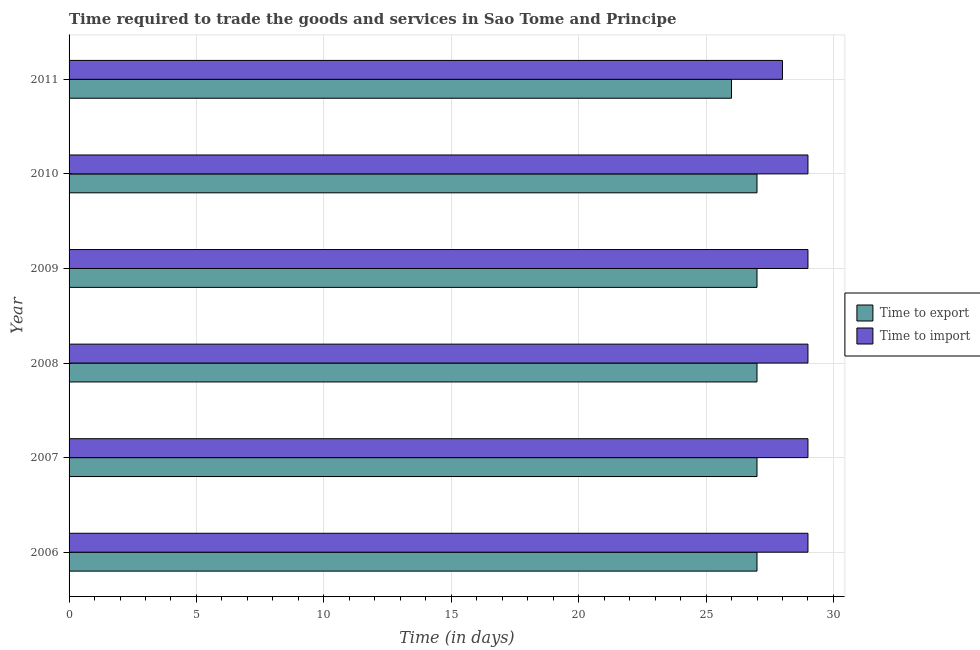How many different coloured bars are there?
Ensure brevity in your answer.  2. Are the number of bars per tick equal to the number of legend labels?
Ensure brevity in your answer.  Yes. Are the number of bars on each tick of the Y-axis equal?
Give a very brief answer. Yes. How many bars are there on the 2nd tick from the bottom?
Your answer should be compact. 2. What is the time to import in 2009?
Make the answer very short. 29. Across all years, what is the maximum time to export?
Make the answer very short. 27. Across all years, what is the minimum time to import?
Your response must be concise. 28. What is the total time to import in the graph?
Your response must be concise. 173. What is the difference between the time to export in 2009 and the time to import in 2007?
Give a very brief answer. -2. What is the average time to import per year?
Provide a short and direct response. 28.83. In the year 2009, what is the difference between the time to import and time to export?
Ensure brevity in your answer.  2. Is the time to import in 2009 less than that in 2011?
Ensure brevity in your answer.  No. What is the difference between the highest and the lowest time to import?
Your answer should be very brief. 1. In how many years, is the time to export greater than the average time to export taken over all years?
Give a very brief answer. 5. What does the 1st bar from the top in 2006 represents?
Keep it short and to the point. Time to import. What does the 2nd bar from the bottom in 2006 represents?
Keep it short and to the point. Time to import. Are all the bars in the graph horizontal?
Offer a terse response. Yes. How many years are there in the graph?
Provide a succinct answer. 6. What is the difference between two consecutive major ticks on the X-axis?
Give a very brief answer. 5. Are the values on the major ticks of X-axis written in scientific E-notation?
Your answer should be very brief. No. Does the graph contain any zero values?
Provide a short and direct response. No. Does the graph contain grids?
Keep it short and to the point. Yes. How are the legend labels stacked?
Offer a terse response. Vertical. What is the title of the graph?
Keep it short and to the point. Time required to trade the goods and services in Sao Tome and Principe. Does "Residents" appear as one of the legend labels in the graph?
Your answer should be very brief. No. What is the label or title of the X-axis?
Your response must be concise. Time (in days). What is the label or title of the Y-axis?
Give a very brief answer. Year. What is the Time (in days) in Time to export in 2006?
Provide a succinct answer. 27. What is the Time (in days) in Time to import in 2006?
Your answer should be very brief. 29. What is the Time (in days) of Time to export in 2007?
Keep it short and to the point. 27. What is the Time (in days) in Time to import in 2007?
Provide a succinct answer. 29. What is the Time (in days) of Time to export in 2008?
Give a very brief answer. 27. What is the Time (in days) of Time to export in 2009?
Your answer should be very brief. 27. What is the Time (in days) in Time to import in 2009?
Provide a short and direct response. 29. What is the Time (in days) of Time to import in 2010?
Provide a short and direct response. 29. What is the Time (in days) of Time to export in 2011?
Make the answer very short. 26. What is the Time (in days) of Time to import in 2011?
Keep it short and to the point. 28. Across all years, what is the maximum Time (in days) in Time to import?
Offer a very short reply. 29. Across all years, what is the minimum Time (in days) in Time to export?
Provide a short and direct response. 26. What is the total Time (in days) in Time to export in the graph?
Offer a terse response. 161. What is the total Time (in days) of Time to import in the graph?
Keep it short and to the point. 173. What is the difference between the Time (in days) of Time to export in 2006 and that in 2007?
Your answer should be compact. 0. What is the difference between the Time (in days) in Time to import in 2006 and that in 2007?
Offer a terse response. 0. What is the difference between the Time (in days) in Time to export in 2006 and that in 2008?
Ensure brevity in your answer.  0. What is the difference between the Time (in days) in Time to import in 2006 and that in 2008?
Offer a terse response. 0. What is the difference between the Time (in days) in Time to export in 2006 and that in 2009?
Provide a succinct answer. 0. What is the difference between the Time (in days) of Time to import in 2006 and that in 2009?
Offer a very short reply. 0. What is the difference between the Time (in days) of Time to export in 2006 and that in 2010?
Ensure brevity in your answer.  0. What is the difference between the Time (in days) of Time to import in 2006 and that in 2010?
Offer a terse response. 0. What is the difference between the Time (in days) in Time to export in 2006 and that in 2011?
Offer a very short reply. 1. What is the difference between the Time (in days) in Time to import in 2006 and that in 2011?
Offer a terse response. 1. What is the difference between the Time (in days) of Time to import in 2007 and that in 2009?
Make the answer very short. 0. What is the difference between the Time (in days) of Time to export in 2007 and that in 2011?
Offer a terse response. 1. What is the difference between the Time (in days) of Time to export in 2008 and that in 2009?
Keep it short and to the point. 0. What is the difference between the Time (in days) of Time to import in 2008 and that in 2009?
Your answer should be compact. 0. What is the difference between the Time (in days) of Time to import in 2008 and that in 2010?
Keep it short and to the point. 0. What is the difference between the Time (in days) in Time to export in 2009 and that in 2010?
Make the answer very short. 0. What is the difference between the Time (in days) in Time to export in 2009 and that in 2011?
Keep it short and to the point. 1. What is the difference between the Time (in days) of Time to import in 2009 and that in 2011?
Your answer should be very brief. 1. What is the difference between the Time (in days) of Time to export in 2006 and the Time (in days) of Time to import in 2009?
Give a very brief answer. -2. What is the difference between the Time (in days) of Time to export in 2006 and the Time (in days) of Time to import in 2011?
Make the answer very short. -1. What is the difference between the Time (in days) in Time to export in 2007 and the Time (in days) in Time to import in 2008?
Your response must be concise. -2. What is the difference between the Time (in days) in Time to export in 2007 and the Time (in days) in Time to import in 2010?
Offer a terse response. -2. What is the difference between the Time (in days) of Time to export in 2008 and the Time (in days) of Time to import in 2010?
Offer a terse response. -2. What is the difference between the Time (in days) of Time to export in 2008 and the Time (in days) of Time to import in 2011?
Make the answer very short. -1. What is the difference between the Time (in days) of Time to export in 2009 and the Time (in days) of Time to import in 2010?
Your response must be concise. -2. What is the difference between the Time (in days) of Time to export in 2010 and the Time (in days) of Time to import in 2011?
Give a very brief answer. -1. What is the average Time (in days) in Time to export per year?
Keep it short and to the point. 26.83. What is the average Time (in days) of Time to import per year?
Your response must be concise. 28.83. In the year 2007, what is the difference between the Time (in days) of Time to export and Time (in days) of Time to import?
Offer a very short reply. -2. In the year 2009, what is the difference between the Time (in days) in Time to export and Time (in days) in Time to import?
Provide a succinct answer. -2. In the year 2010, what is the difference between the Time (in days) in Time to export and Time (in days) in Time to import?
Provide a short and direct response. -2. What is the ratio of the Time (in days) of Time to export in 2006 to that in 2007?
Your answer should be very brief. 1. What is the ratio of the Time (in days) of Time to import in 2006 to that in 2007?
Give a very brief answer. 1. What is the ratio of the Time (in days) in Time to import in 2006 to that in 2009?
Provide a succinct answer. 1. What is the ratio of the Time (in days) in Time to import in 2006 to that in 2010?
Offer a terse response. 1. What is the ratio of the Time (in days) of Time to export in 2006 to that in 2011?
Provide a succinct answer. 1.04. What is the ratio of the Time (in days) of Time to import in 2006 to that in 2011?
Your response must be concise. 1.04. What is the ratio of the Time (in days) in Time to import in 2007 to that in 2009?
Provide a short and direct response. 1. What is the ratio of the Time (in days) of Time to import in 2007 to that in 2010?
Your answer should be very brief. 1. What is the ratio of the Time (in days) in Time to export in 2007 to that in 2011?
Your response must be concise. 1.04. What is the ratio of the Time (in days) in Time to import in 2007 to that in 2011?
Offer a terse response. 1.04. What is the ratio of the Time (in days) in Time to export in 2008 to that in 2009?
Keep it short and to the point. 1. What is the ratio of the Time (in days) in Time to import in 2008 to that in 2009?
Offer a very short reply. 1. What is the ratio of the Time (in days) of Time to export in 2008 to that in 2010?
Keep it short and to the point. 1. What is the ratio of the Time (in days) in Time to import in 2008 to that in 2011?
Your answer should be compact. 1.04. What is the ratio of the Time (in days) of Time to import in 2009 to that in 2010?
Provide a succinct answer. 1. What is the ratio of the Time (in days) of Time to export in 2009 to that in 2011?
Your answer should be compact. 1.04. What is the ratio of the Time (in days) of Time to import in 2009 to that in 2011?
Offer a terse response. 1.04. What is the ratio of the Time (in days) of Time to export in 2010 to that in 2011?
Your answer should be compact. 1.04. What is the ratio of the Time (in days) of Time to import in 2010 to that in 2011?
Make the answer very short. 1.04. What is the difference between the highest and the second highest Time (in days) in Time to import?
Make the answer very short. 0. 